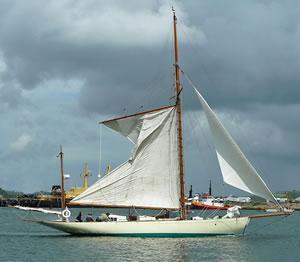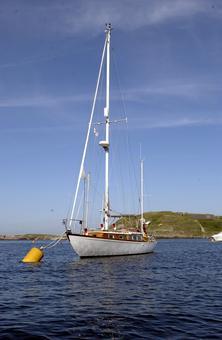The first image is the image on the left, the second image is the image on the right. Considering the images on both sides, is "The sails on one of the ships is fully extended." valid? Answer yes or no. Yes. The first image is the image on the left, the second image is the image on the right. Considering the images on both sides, is "A grassy hill is in the background of a sailboat." valid? Answer yes or no. Yes. 